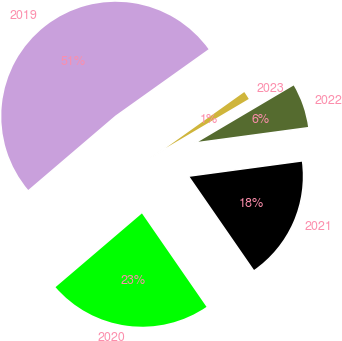<chart> <loc_0><loc_0><loc_500><loc_500><pie_chart><fcel>2019<fcel>2020<fcel>2021<fcel>2022<fcel>2023<nl><fcel>51.4%<fcel>23.38%<fcel>17.51%<fcel>6.36%<fcel>1.36%<nl></chart> 